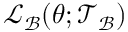<formula> <loc_0><loc_0><loc_500><loc_500>\mathcal { L } _ { \mathcal { B } } ( \theta ; \mathcal { T } _ { \mathcal { B } } )</formula> 